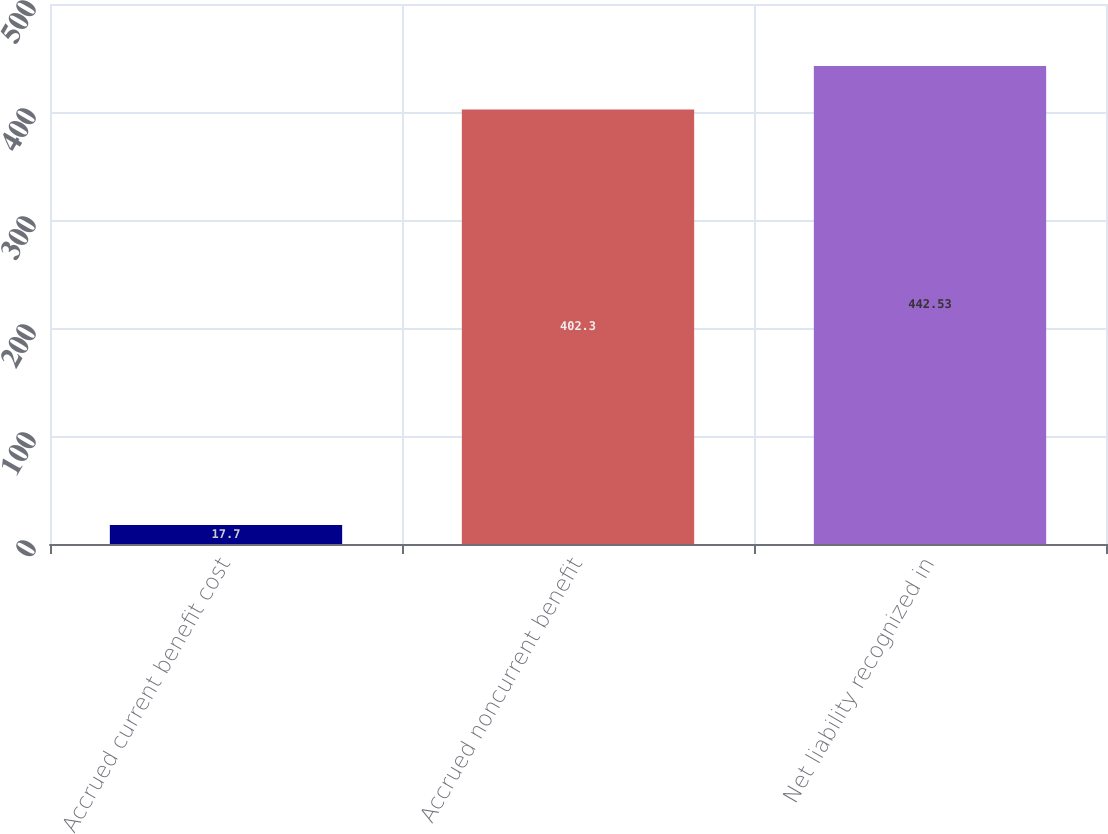Convert chart. <chart><loc_0><loc_0><loc_500><loc_500><bar_chart><fcel>Accrued current benefit cost<fcel>Accrued noncurrent benefit<fcel>Net liability recognized in<nl><fcel>17.7<fcel>402.3<fcel>442.53<nl></chart> 